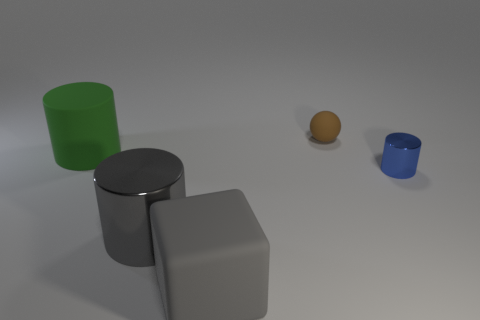Subtract all tiny blue cylinders. How many cylinders are left? 2 Subtract all brown cylinders. Subtract all red cubes. How many cylinders are left? 3 Subtract all blue cubes. How many cyan spheres are left? 0 Subtract all green matte things. Subtract all large rubber blocks. How many objects are left? 3 Add 4 small brown rubber spheres. How many small brown rubber spheres are left? 5 Add 4 small metal objects. How many small metal objects exist? 5 Add 5 tiny blue metal cylinders. How many objects exist? 10 Subtract all gray cylinders. How many cylinders are left? 2 Subtract 0 purple blocks. How many objects are left? 5 Subtract all blocks. How many objects are left? 4 